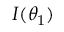<formula> <loc_0><loc_0><loc_500><loc_500>I ( \theta _ { 1 } )</formula> 